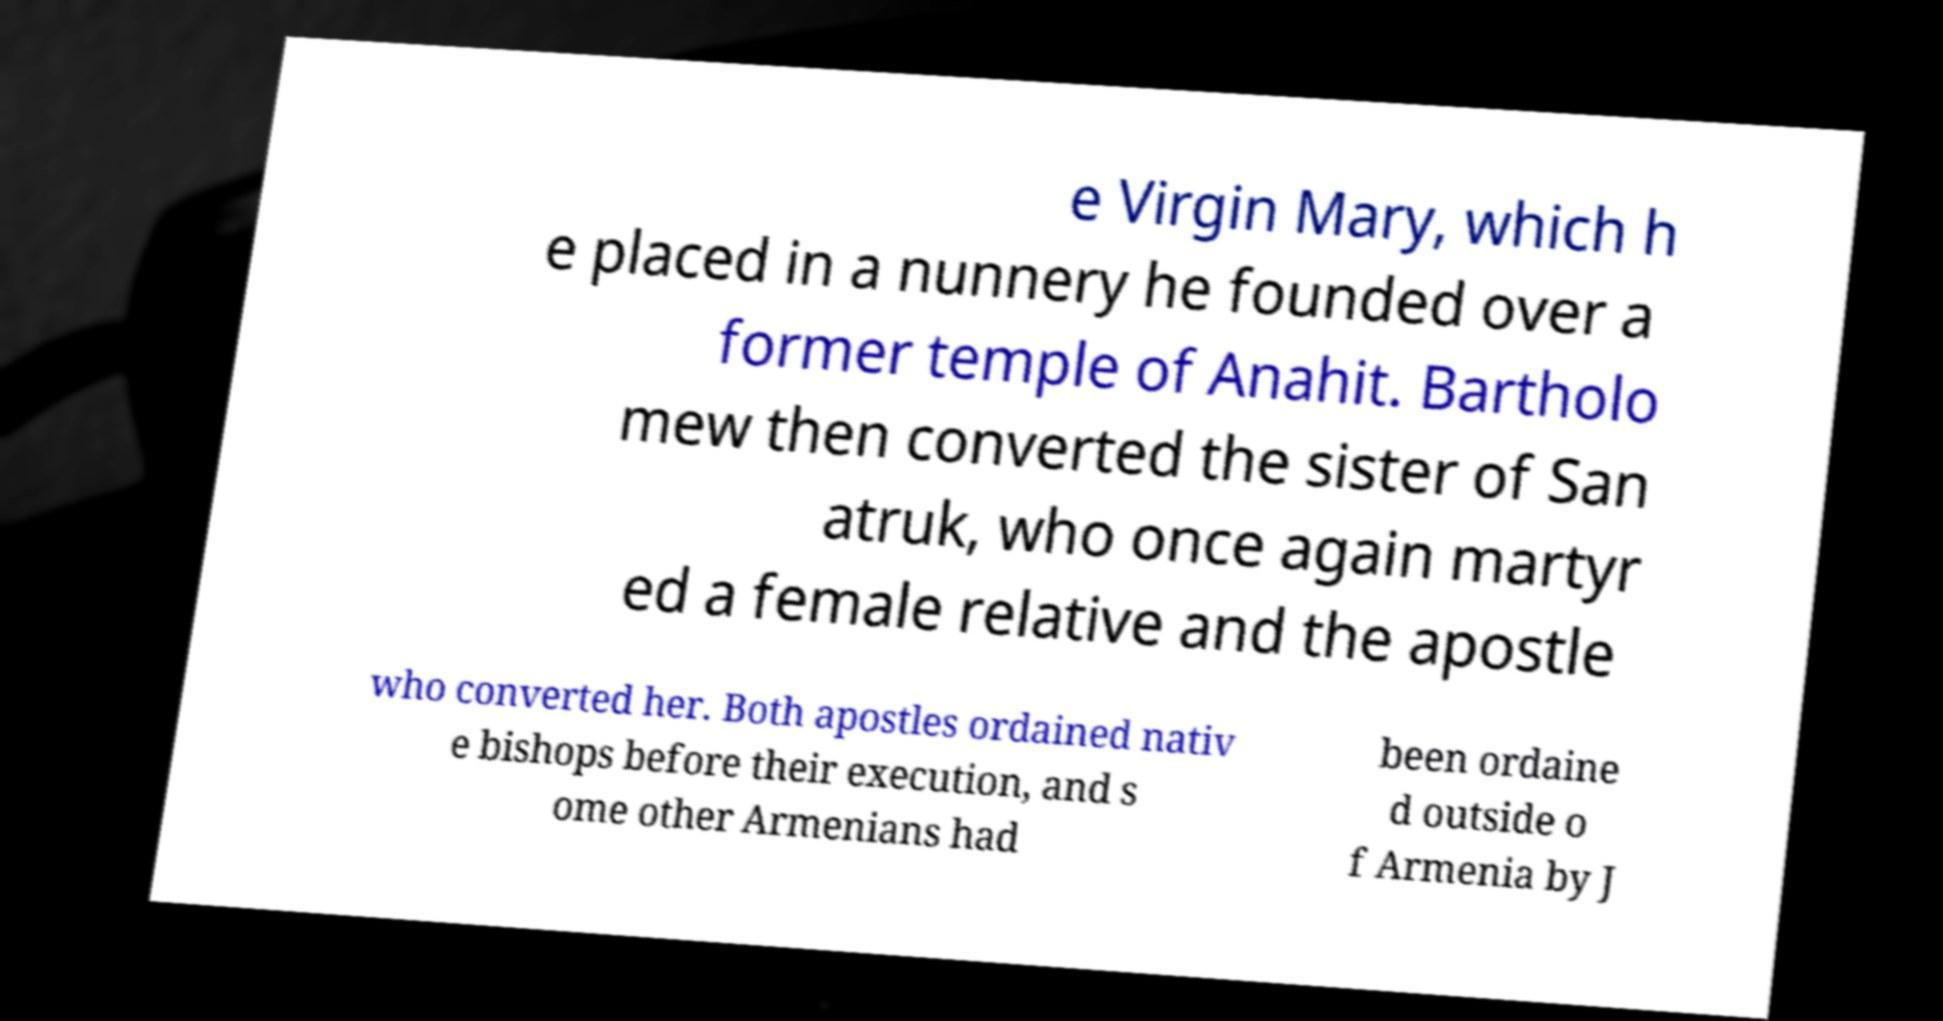Please identify and transcribe the text found in this image. e Virgin Mary, which h e placed in a nunnery he founded over a former temple of Anahit. Bartholo mew then converted the sister of San atruk, who once again martyr ed a female relative and the apostle who converted her. Both apostles ordained nativ e bishops before their execution, and s ome other Armenians had been ordaine d outside o f Armenia by J 